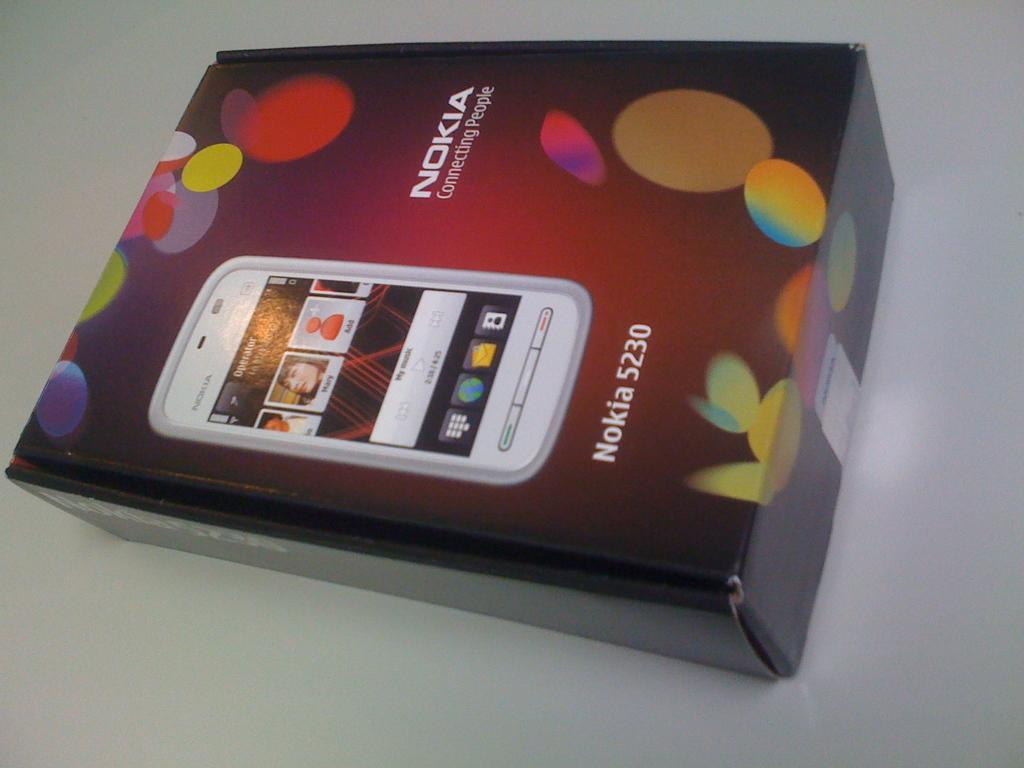Provide a one-sentence caption for the provided image. A box for Nokia 5230 miobile phone has a picture of the phone on it. 